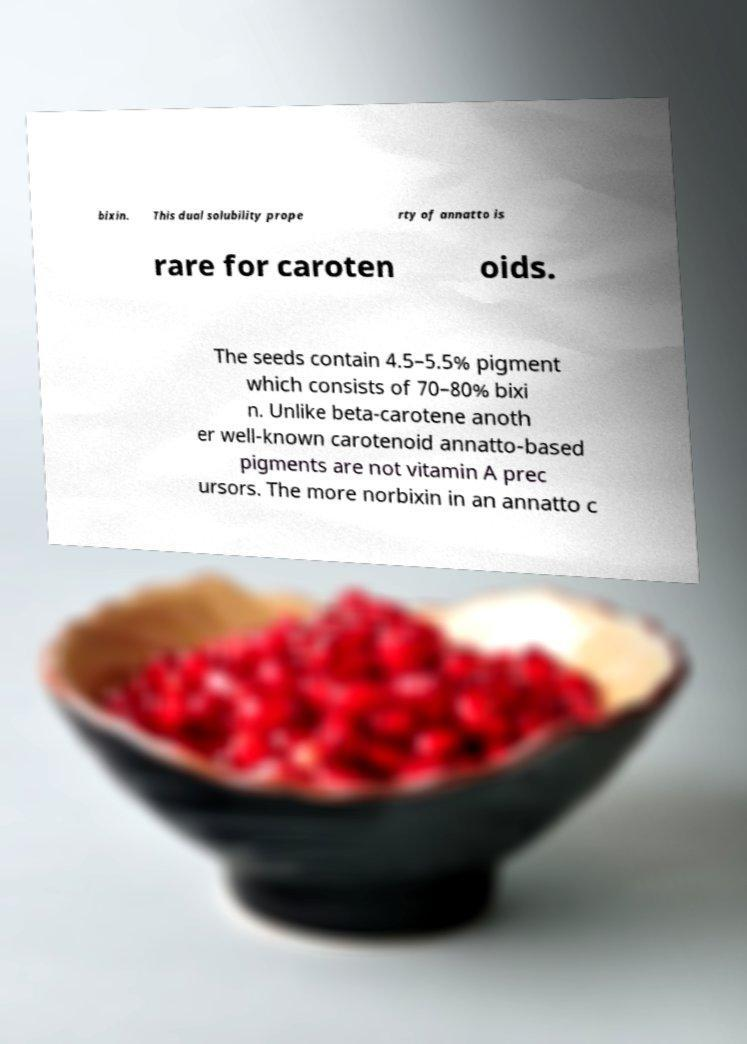I need the written content from this picture converted into text. Can you do that? bixin. This dual solubility prope rty of annatto is rare for caroten oids. The seeds contain 4.5–5.5% pigment which consists of 70–80% bixi n. Unlike beta-carotene anoth er well-known carotenoid annatto-based pigments are not vitamin A prec ursors. The more norbixin in an annatto c 